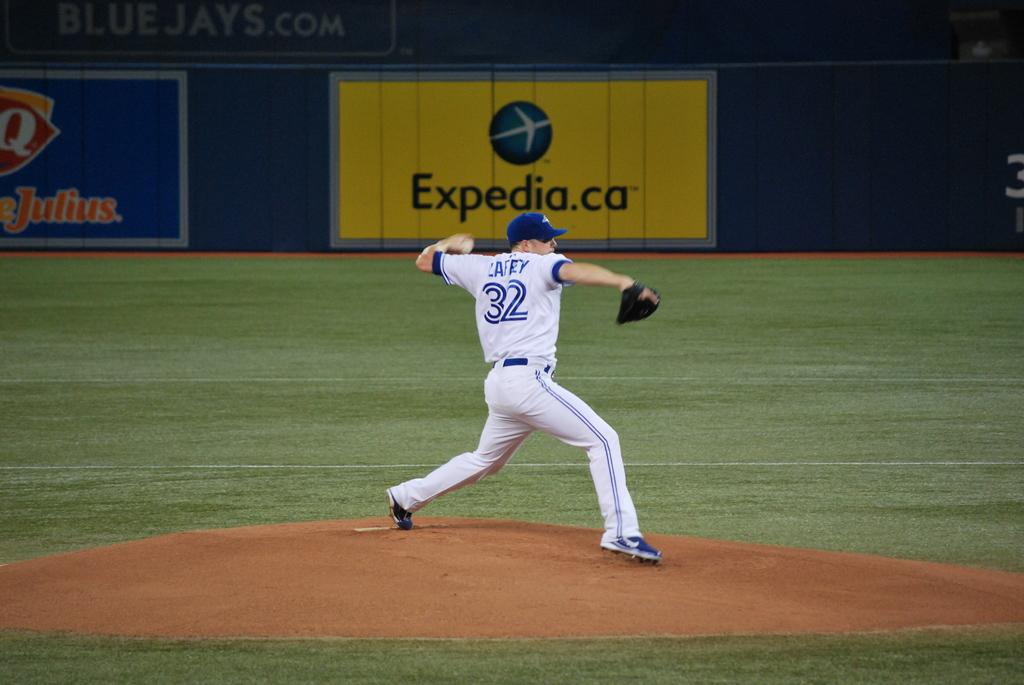<image>
Create a compact narrative representing the image presented. Baseball player playing in front of an ad for Expedia. 